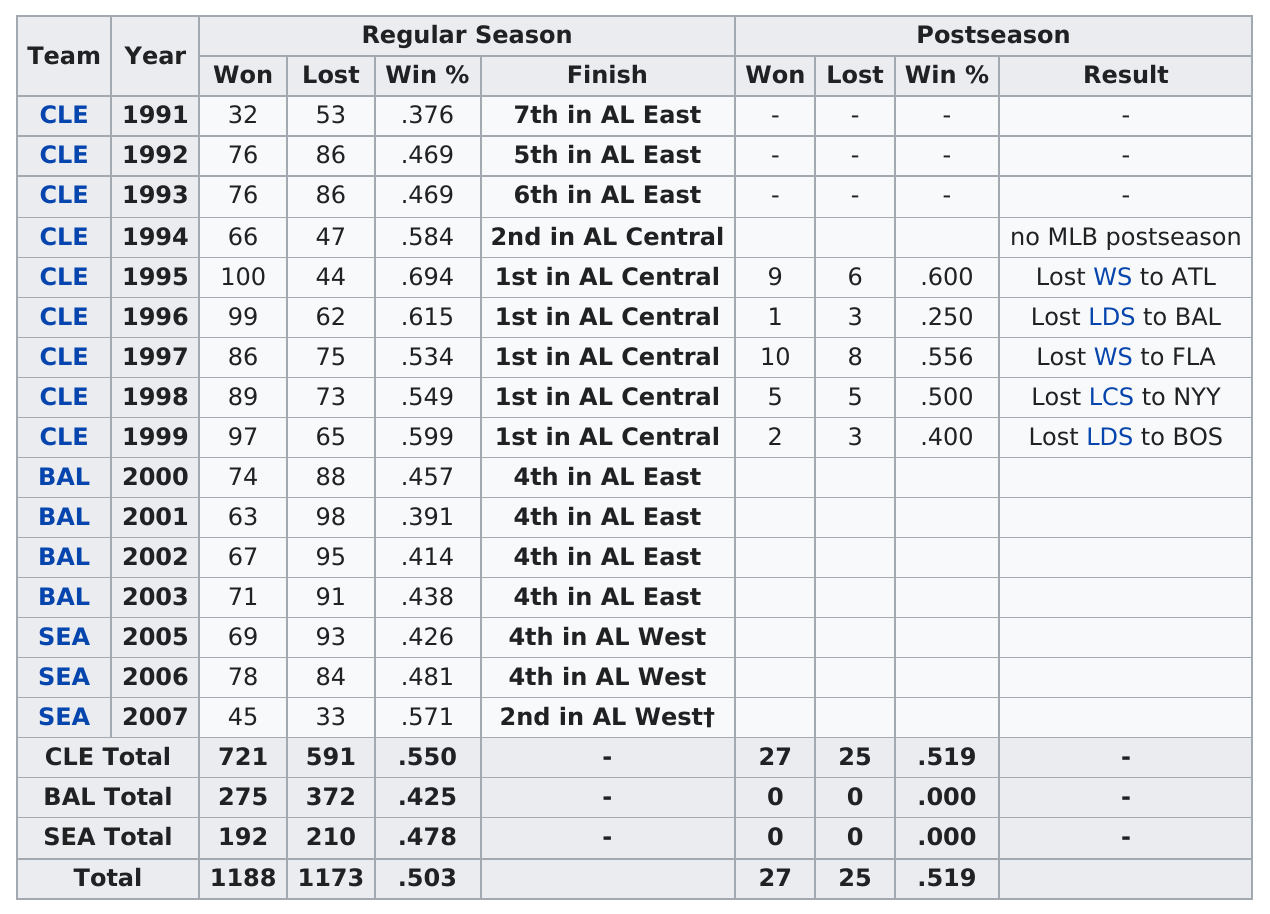Give some essential details in this illustration. Cleveland has the most wins among all teams. 